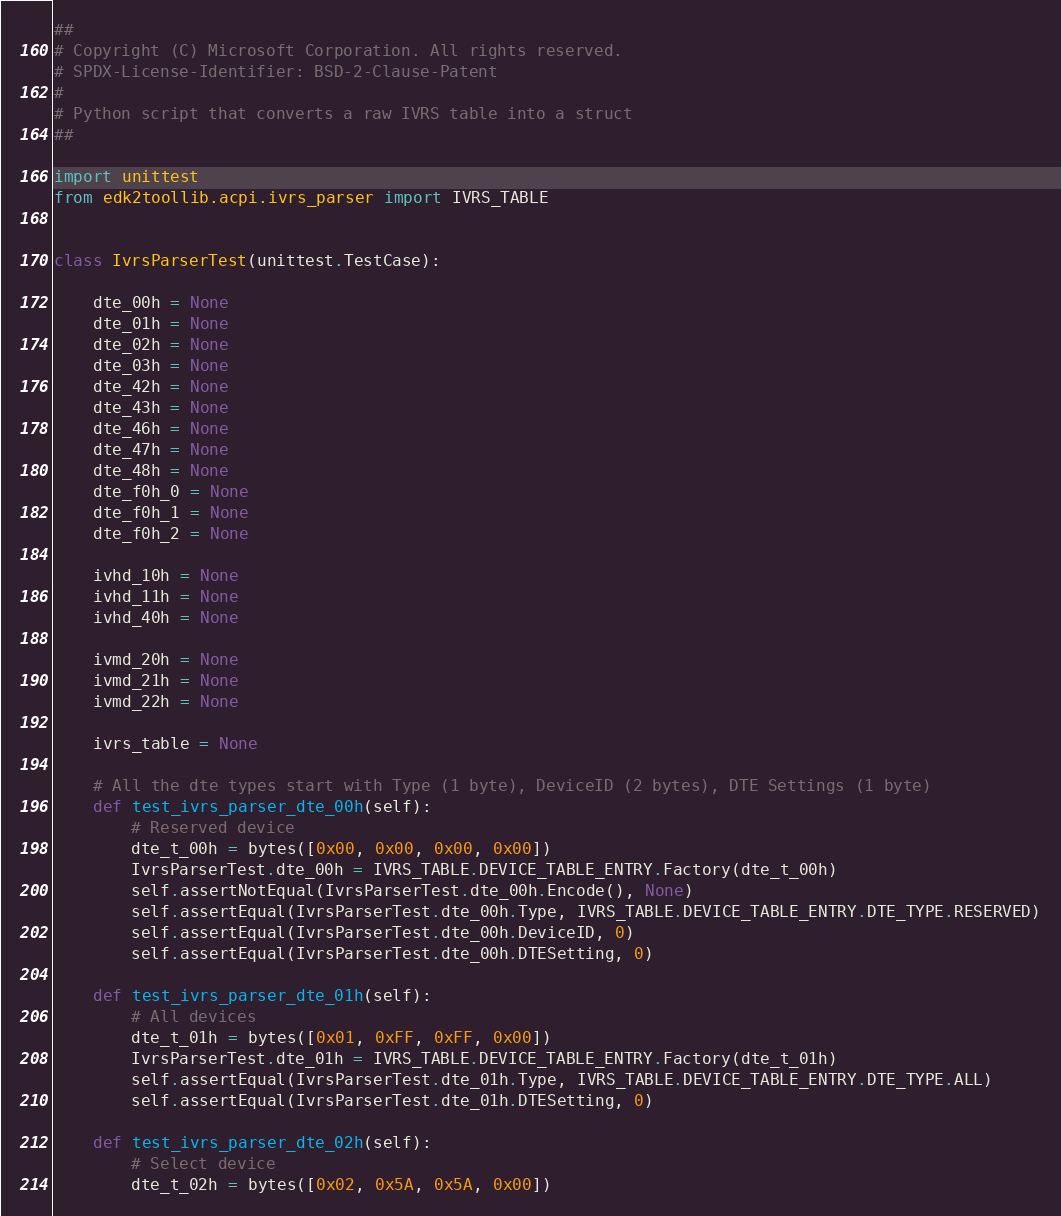<code> <loc_0><loc_0><loc_500><loc_500><_Python_>##
# Copyright (C) Microsoft Corporation. All rights reserved.
# SPDX-License-Identifier: BSD-2-Clause-Patent
#
# Python script that converts a raw IVRS table into a struct
##

import unittest
from edk2toollib.acpi.ivrs_parser import IVRS_TABLE


class IvrsParserTest(unittest.TestCase):

    dte_00h = None
    dte_01h = None
    dte_02h = None
    dte_03h = None
    dte_42h = None
    dte_43h = None
    dte_46h = None
    dte_47h = None
    dte_48h = None
    dte_f0h_0 = None
    dte_f0h_1 = None
    dte_f0h_2 = None

    ivhd_10h = None
    ivhd_11h = None
    ivhd_40h = None

    ivmd_20h = None
    ivmd_21h = None
    ivmd_22h = None

    ivrs_table = None

    # All the dte types start with Type (1 byte), DeviceID (2 bytes), DTE Settings (1 byte)
    def test_ivrs_parser_dte_00h(self):
        # Reserved device
        dte_t_00h = bytes([0x00, 0x00, 0x00, 0x00])
        IvrsParserTest.dte_00h = IVRS_TABLE.DEVICE_TABLE_ENTRY.Factory(dte_t_00h)
        self.assertNotEqual(IvrsParserTest.dte_00h.Encode(), None)
        self.assertEqual(IvrsParserTest.dte_00h.Type, IVRS_TABLE.DEVICE_TABLE_ENTRY.DTE_TYPE.RESERVED)
        self.assertEqual(IvrsParserTest.dte_00h.DeviceID, 0)
        self.assertEqual(IvrsParserTest.dte_00h.DTESetting, 0)

    def test_ivrs_parser_dte_01h(self):
        # All devices
        dte_t_01h = bytes([0x01, 0xFF, 0xFF, 0x00])
        IvrsParserTest.dte_01h = IVRS_TABLE.DEVICE_TABLE_ENTRY.Factory(dte_t_01h)
        self.assertEqual(IvrsParserTest.dte_01h.Type, IVRS_TABLE.DEVICE_TABLE_ENTRY.DTE_TYPE.ALL)
        self.assertEqual(IvrsParserTest.dte_01h.DTESetting, 0)

    def test_ivrs_parser_dte_02h(self):
        # Select device
        dte_t_02h = bytes([0x02, 0x5A, 0x5A, 0x00])</code> 